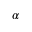Convert formula to latex. <formula><loc_0><loc_0><loc_500><loc_500>\alpha</formula> 